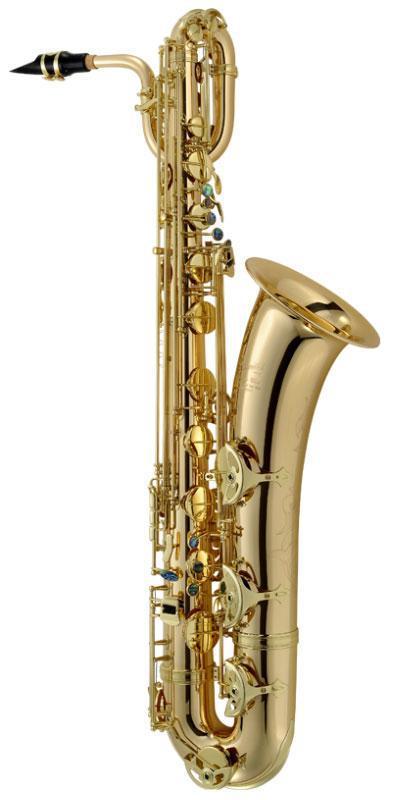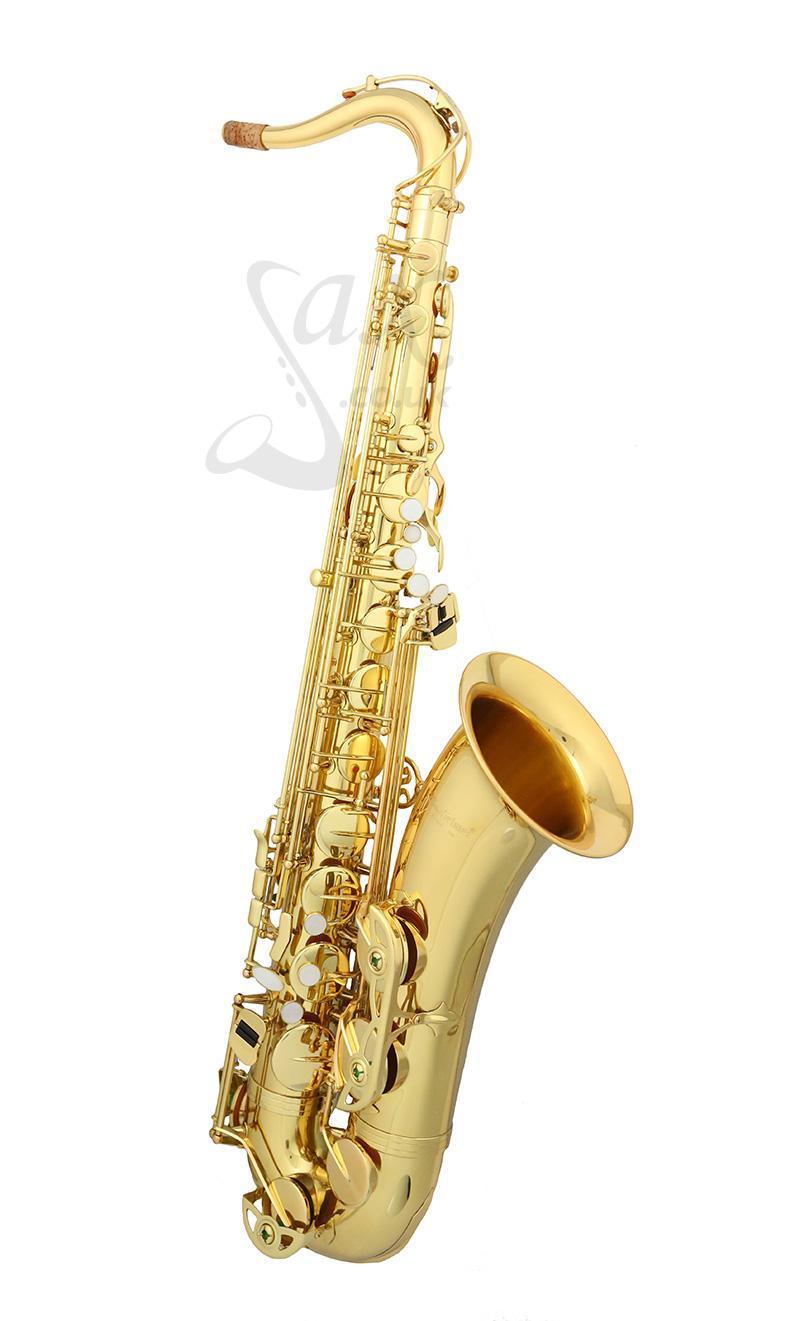The first image is the image on the left, the second image is the image on the right. For the images shown, is this caption "The saxophone on the left has a black mouthpiece and is displayed vertically, while the saxophone on the right has no dark mouthpiece and is tilted to the right." true? Answer yes or no. Yes. 